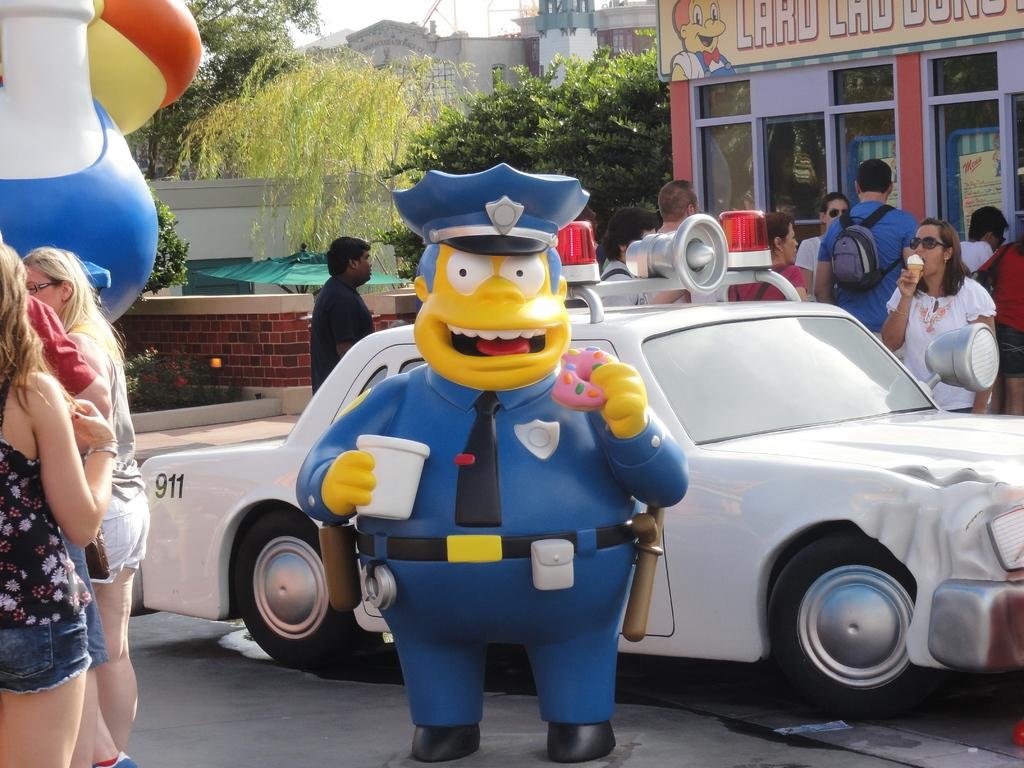What is the main subject of the image? There is a vehicle in the image. What else can be seen in the image besides the vehicle? There are people on the road and buildings and trees in the background of the image. What type of milk is being used to water the plants in the image? There are no plants or milk present in the image. What type of voyage is the vehicle taking in the image? The image does not provide information about the vehicle's destination or purpose, so it cannot be determined if it is on a voyage. 